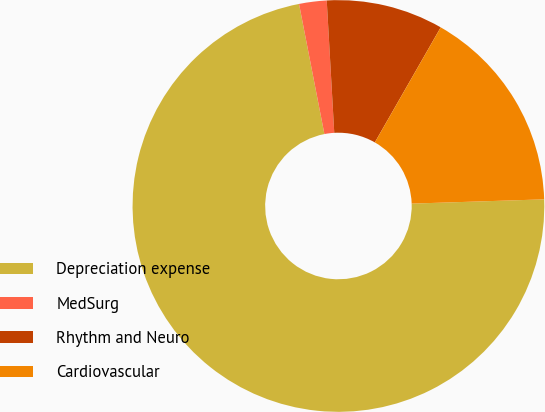Convert chart. <chart><loc_0><loc_0><loc_500><loc_500><pie_chart><fcel>Depreciation expense<fcel>MedSurg<fcel>Rhythm and Neuro<fcel>Cardiovascular<nl><fcel>72.45%<fcel>2.16%<fcel>9.18%<fcel>16.21%<nl></chart> 